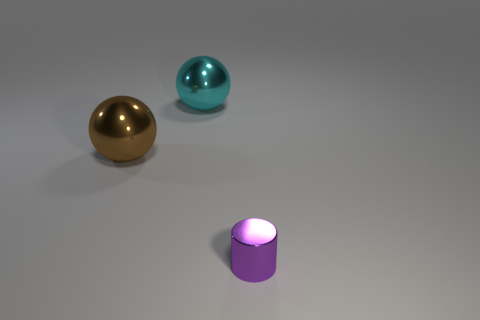Add 2 small cylinders. How many objects exist? 5 Subtract all balls. How many objects are left? 1 Subtract all small purple things. Subtract all large red objects. How many objects are left? 2 Add 3 cyan things. How many cyan things are left? 4 Add 2 small gray spheres. How many small gray spheres exist? 2 Subtract 0 purple balls. How many objects are left? 3 